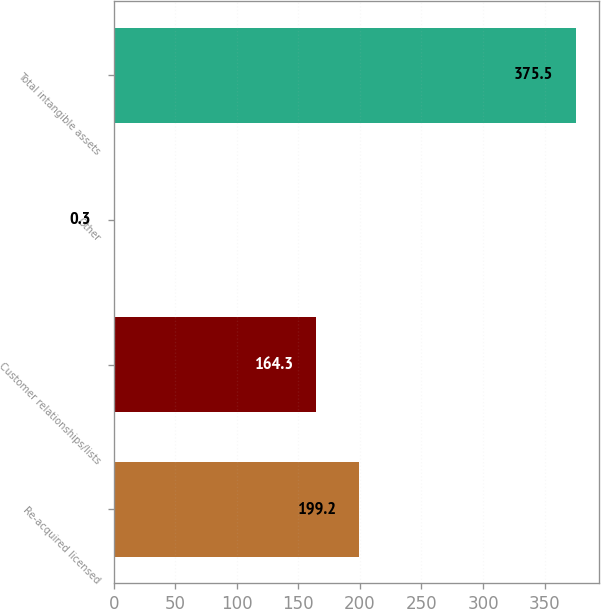<chart> <loc_0><loc_0><loc_500><loc_500><bar_chart><fcel>Re-acquired licensed<fcel>Customer relationships/lists<fcel>Other<fcel>Total intangible assets<nl><fcel>199.2<fcel>164.3<fcel>0.3<fcel>375.5<nl></chart> 